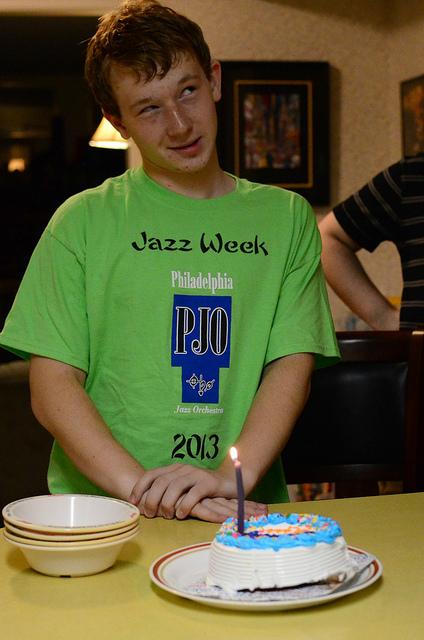Are there any lit candles on the cake?
Concise answer only. Yes. How many bowls are shown?
Quick response, please. 4. What is the boy wearing?
Give a very brief answer. T shirt. 